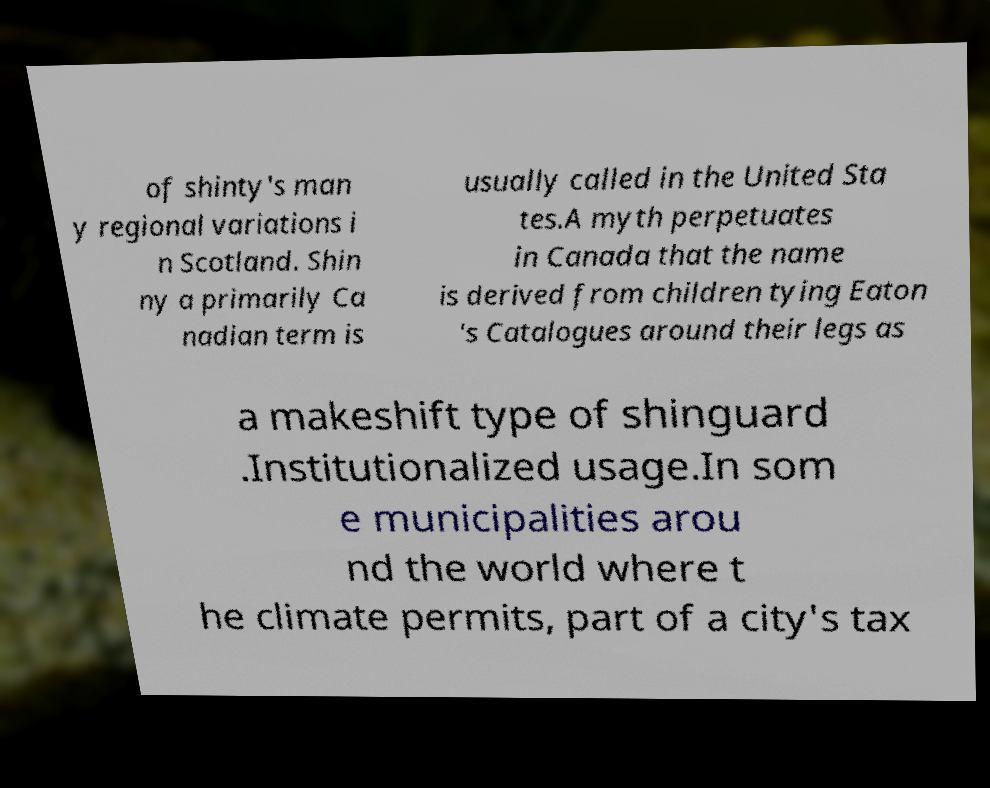Could you assist in decoding the text presented in this image and type it out clearly? of shinty's man y regional variations i n Scotland. Shin ny a primarily Ca nadian term is usually called in the United Sta tes.A myth perpetuates in Canada that the name is derived from children tying Eaton 's Catalogues around their legs as a makeshift type of shinguard .Institutionalized usage.In som e municipalities arou nd the world where t he climate permits, part of a city's tax 